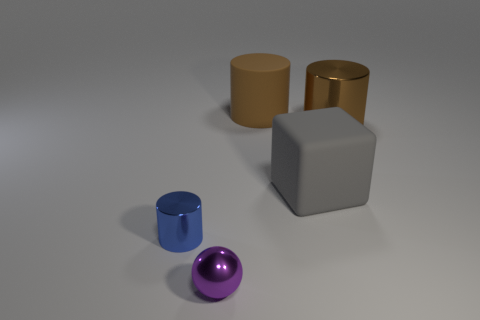Subtract all large rubber cylinders. How many cylinders are left? 2 Subtract all blue cylinders. How many cylinders are left? 2 Add 5 small yellow metallic cylinders. How many objects exist? 10 Subtract all cylinders. How many objects are left? 2 Subtract all purple cylinders. Subtract all green blocks. How many cylinders are left? 3 Subtract all blue cubes. How many brown cylinders are left? 2 Subtract all big purple rubber balls. Subtract all matte cubes. How many objects are left? 4 Add 5 matte blocks. How many matte blocks are left? 6 Add 2 tiny purple metallic cylinders. How many tiny purple metallic cylinders exist? 2 Subtract 0 yellow balls. How many objects are left? 5 